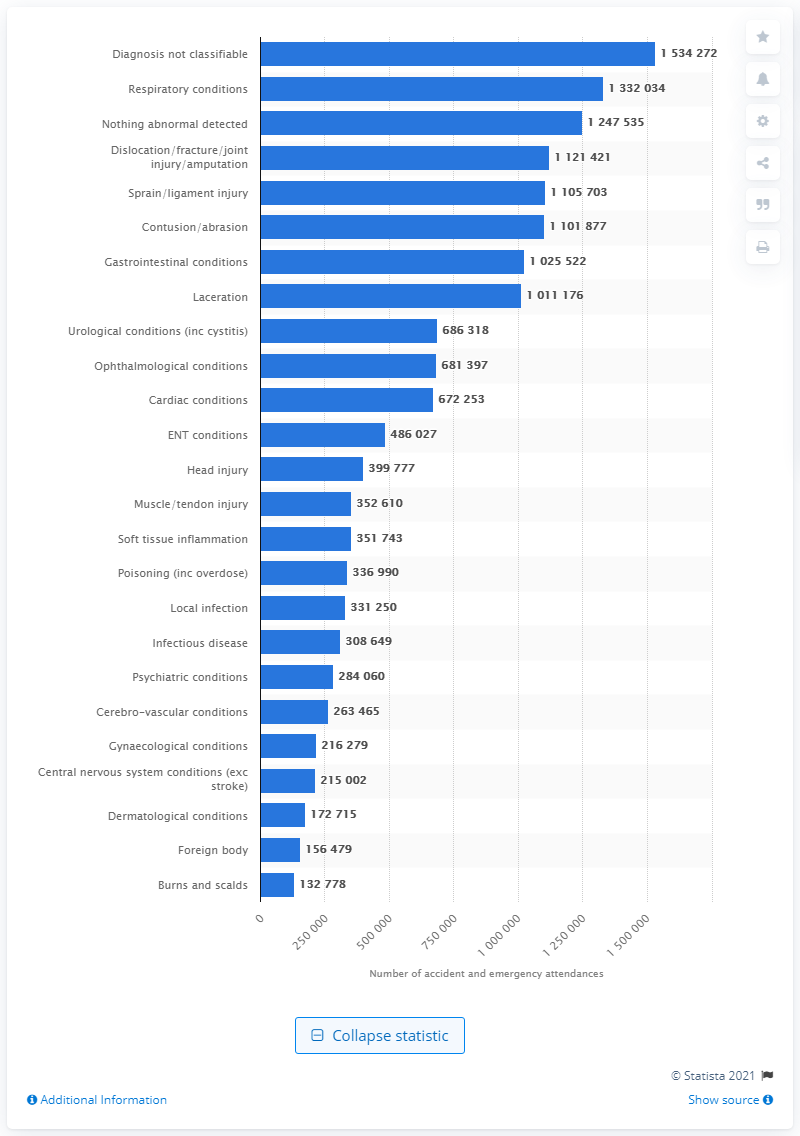Mention a couple of crucial points in this snapshot. In the 2019/2020 fiscal year, a total of 133,2034 people attended the accident and emergency department and received a first diagnosis of respiratory conditions. 